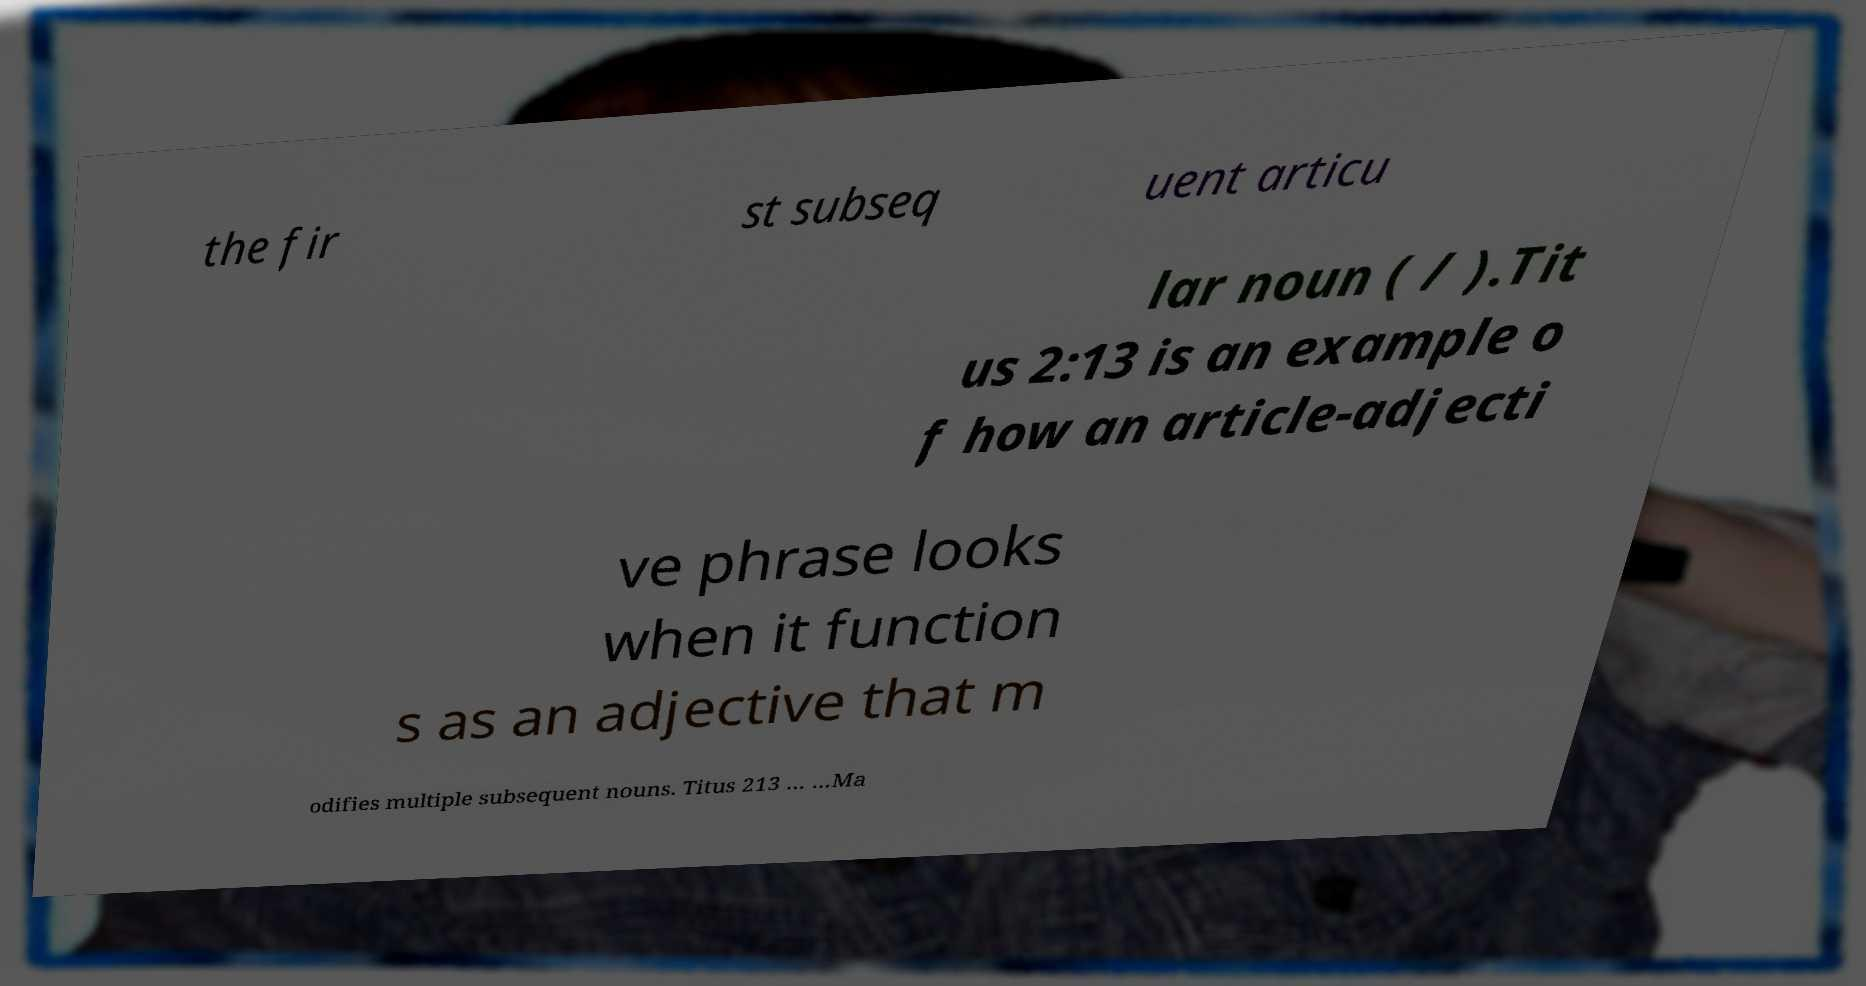Could you extract and type out the text from this image? the fir st subseq uent articu lar noun ( / ).Tit us 2:13 is an example o f how an article-adjecti ve phrase looks when it function s as an adjective that m odifies multiple subsequent nouns. Titus 213 … …Ma 